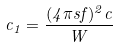<formula> <loc_0><loc_0><loc_500><loc_500>c _ { 1 } = \frac { ( 4 \pi s f ) ^ { 2 } c } { W }</formula> 